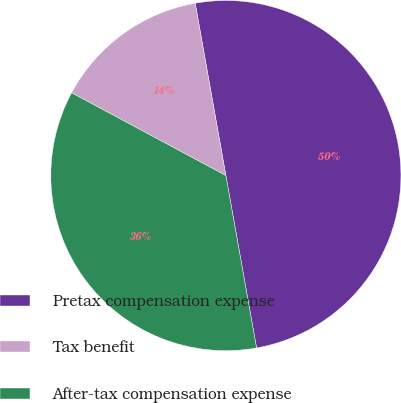<chart> <loc_0><loc_0><loc_500><loc_500><pie_chart><fcel>Pretax compensation expense<fcel>Tax benefit<fcel>After-tax compensation expense<nl><fcel>50.0%<fcel>14.36%<fcel>35.64%<nl></chart> 